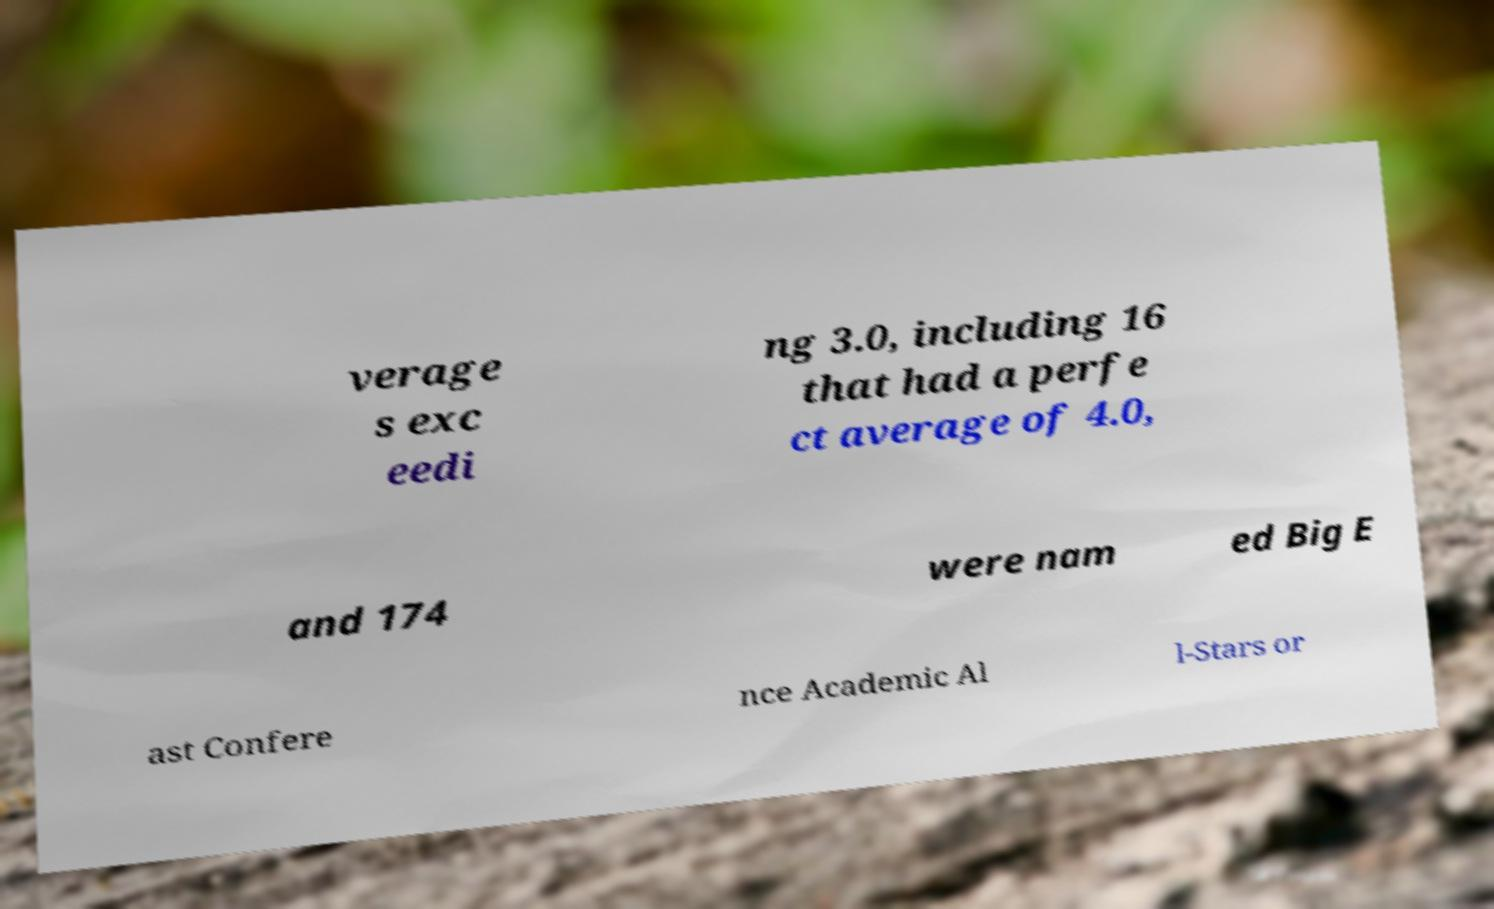Please read and relay the text visible in this image. What does it say? verage s exc eedi ng 3.0, including 16 that had a perfe ct average of 4.0, and 174 were nam ed Big E ast Confere nce Academic Al l-Stars or 